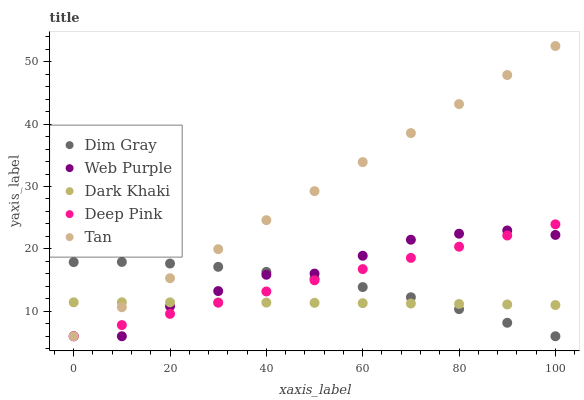Does Dark Khaki have the minimum area under the curve?
Answer yes or no. Yes. Does Tan have the maximum area under the curve?
Answer yes or no. Yes. Does Web Purple have the minimum area under the curve?
Answer yes or no. No. Does Web Purple have the maximum area under the curve?
Answer yes or no. No. Is Deep Pink the smoothest?
Answer yes or no. Yes. Is Web Purple the roughest?
Answer yes or no. Yes. Is Dim Gray the smoothest?
Answer yes or no. No. Is Dim Gray the roughest?
Answer yes or no. No. Does Web Purple have the lowest value?
Answer yes or no. Yes. Does Tan have the highest value?
Answer yes or no. Yes. Does Web Purple have the highest value?
Answer yes or no. No. Does Dark Khaki intersect Deep Pink?
Answer yes or no. Yes. Is Dark Khaki less than Deep Pink?
Answer yes or no. No. Is Dark Khaki greater than Deep Pink?
Answer yes or no. No. 